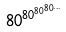<formula> <loc_0><loc_0><loc_500><loc_500>8 0 ^ { 8 0 ^ { 8 0 ^ { 8 0 ^ { \dots } } } }</formula> 